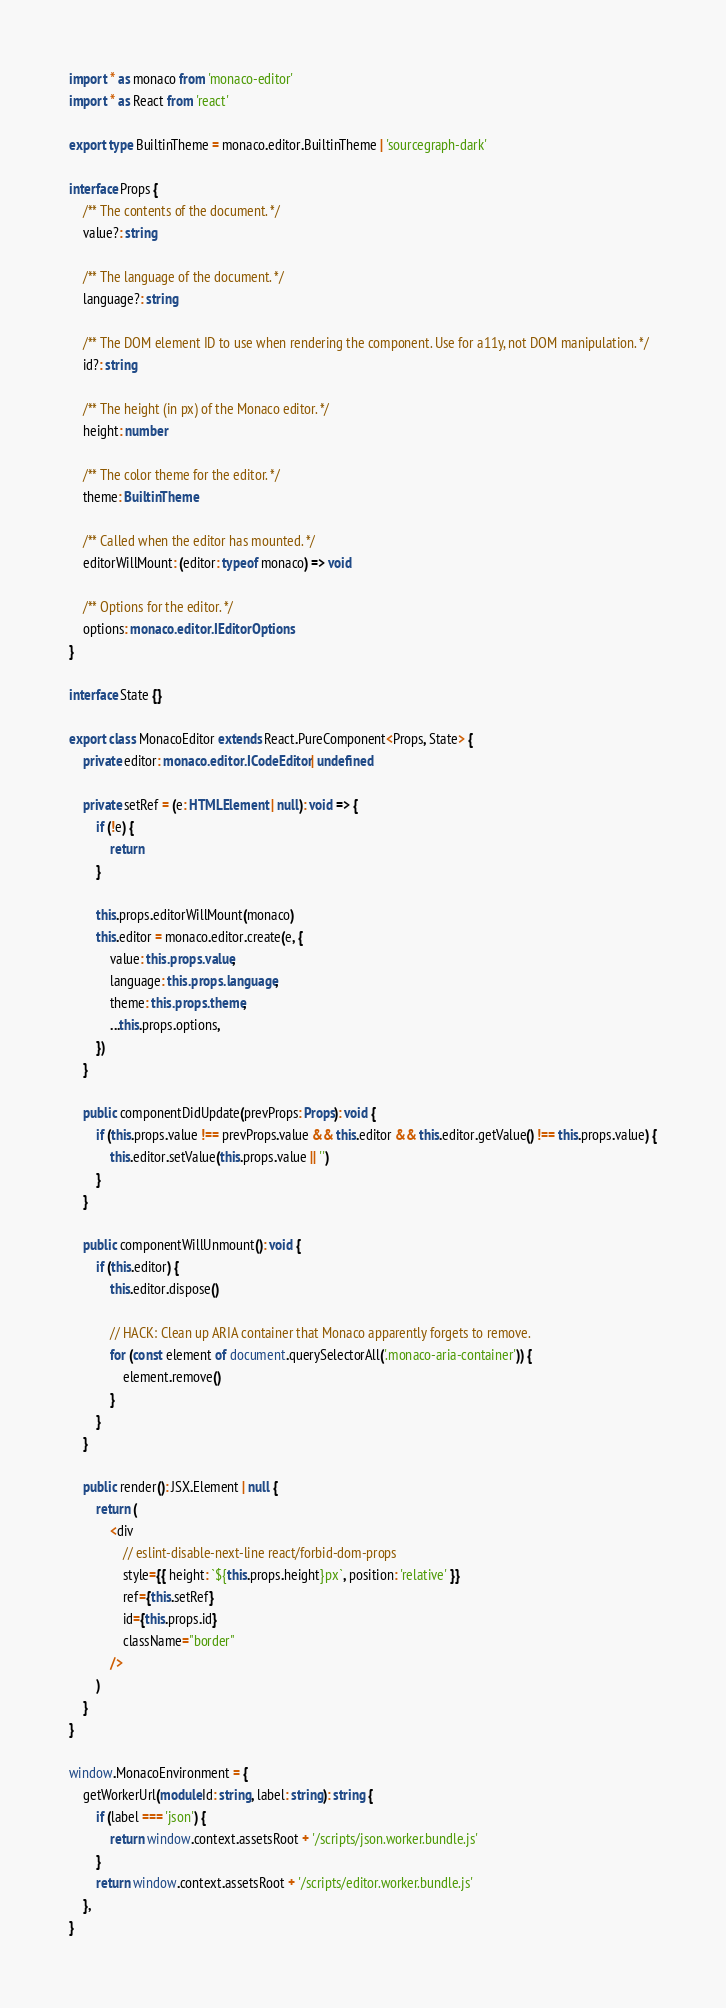<code> <loc_0><loc_0><loc_500><loc_500><_TypeScript_>import * as monaco from 'monaco-editor'
import * as React from 'react'

export type BuiltinTheme = monaco.editor.BuiltinTheme | 'sourcegraph-dark'

interface Props {
    /** The contents of the document. */
    value?: string

    /** The language of the document. */
    language?: string

    /** The DOM element ID to use when rendering the component. Use for a11y, not DOM manipulation. */
    id?: string

    /** The height (in px) of the Monaco editor. */
    height: number

    /** The color theme for the editor. */
    theme: BuiltinTheme

    /** Called when the editor has mounted. */
    editorWillMount: (editor: typeof monaco) => void

    /** Options for the editor. */
    options: monaco.editor.IEditorOptions
}

interface State {}

export class MonacoEditor extends React.PureComponent<Props, State> {
    private editor: monaco.editor.ICodeEditor | undefined

    private setRef = (e: HTMLElement | null): void => {
        if (!e) {
            return
        }

        this.props.editorWillMount(monaco)
        this.editor = monaco.editor.create(e, {
            value: this.props.value,
            language: this.props.language,
            theme: this.props.theme,
            ...this.props.options,
        })
    }

    public componentDidUpdate(prevProps: Props): void {
        if (this.props.value !== prevProps.value && this.editor && this.editor.getValue() !== this.props.value) {
            this.editor.setValue(this.props.value || '')
        }
    }

    public componentWillUnmount(): void {
        if (this.editor) {
            this.editor.dispose()

            // HACK: Clean up ARIA container that Monaco apparently forgets to remove.
            for (const element of document.querySelectorAll('.monaco-aria-container')) {
                element.remove()
            }
        }
    }

    public render(): JSX.Element | null {
        return (
            <div
                // eslint-disable-next-line react/forbid-dom-props
                style={{ height: `${this.props.height}px`, position: 'relative' }}
                ref={this.setRef}
                id={this.props.id}
                className="border"
            />
        )
    }
}

window.MonacoEnvironment = {
    getWorkerUrl(moduleId: string, label: string): string {
        if (label === 'json') {
            return window.context.assetsRoot + '/scripts/json.worker.bundle.js'
        }
        return window.context.assetsRoot + '/scripts/editor.worker.bundle.js'
    },
}
</code> 